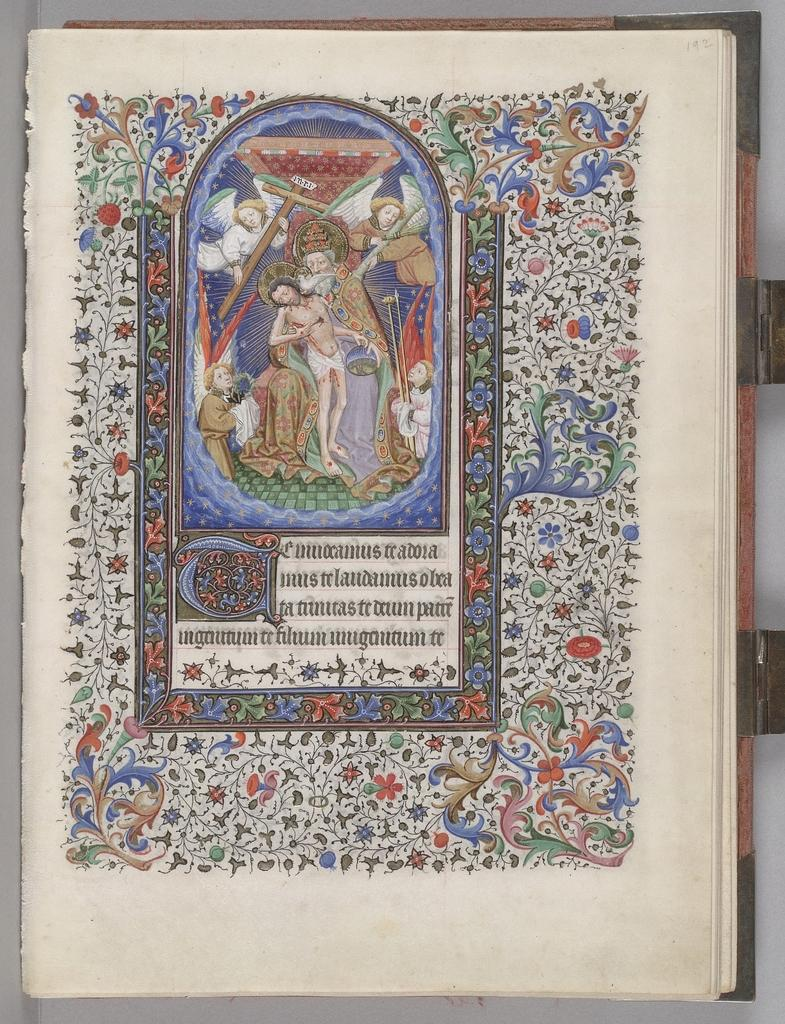What is the main subject of the image? The main subject of the image is a chart. What is depicted within the chart? The chart contains a painting of some persons. Are there any written elements in the image? Yes, there is text in the image. What can be found in the middle of the image? There are designs in the middle of the image. What type of credit can be seen in the image? There is no credit visible in the image, as it contains a chart with a painting of persons, text, and designs. Can you recite the verse that is written in the image? There is no verse present in the image; it contains a chart with a painting of persons, text, and designs. 